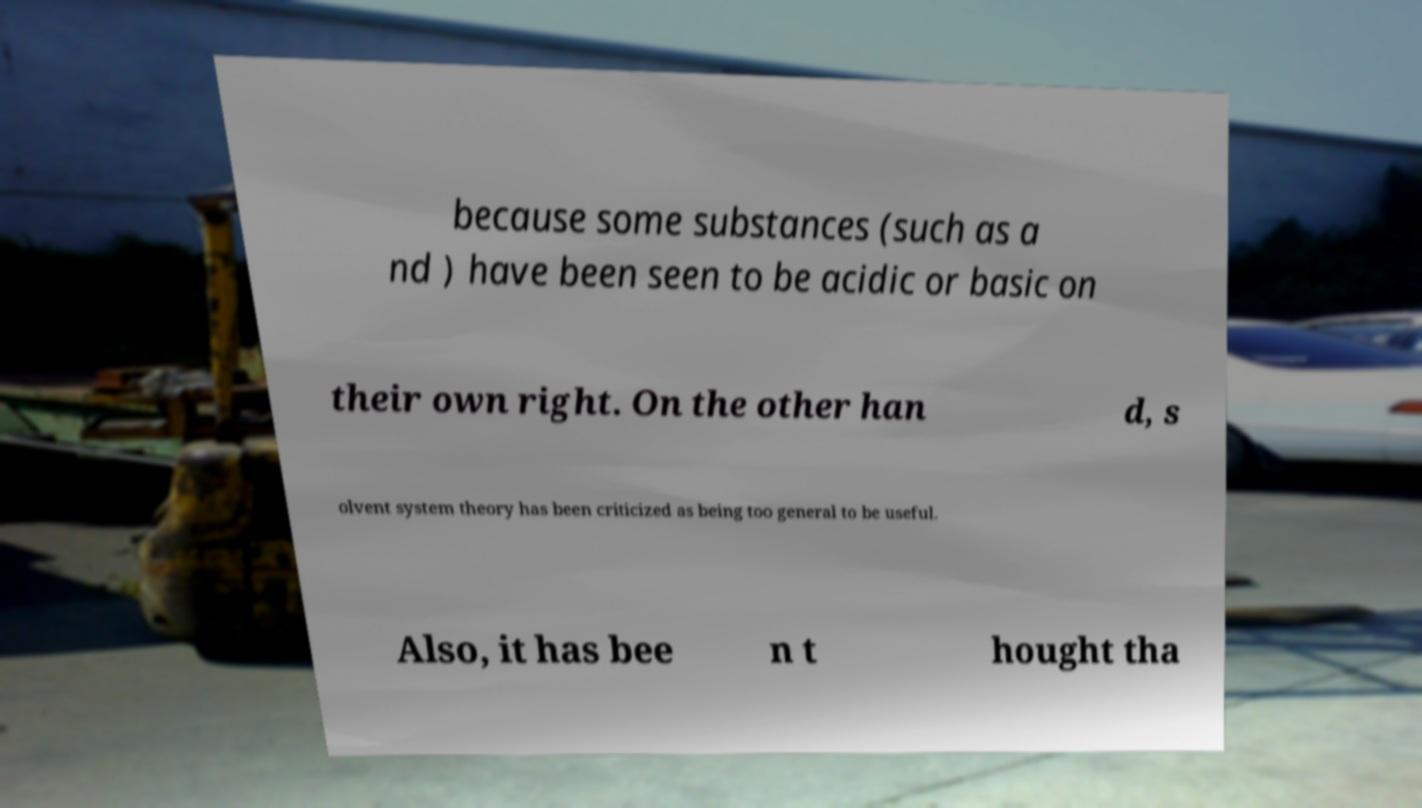Could you assist in decoding the text presented in this image and type it out clearly? because some substances (such as a nd ) have been seen to be acidic or basic on their own right. On the other han d, s olvent system theory has been criticized as being too general to be useful. Also, it has bee n t hought tha 